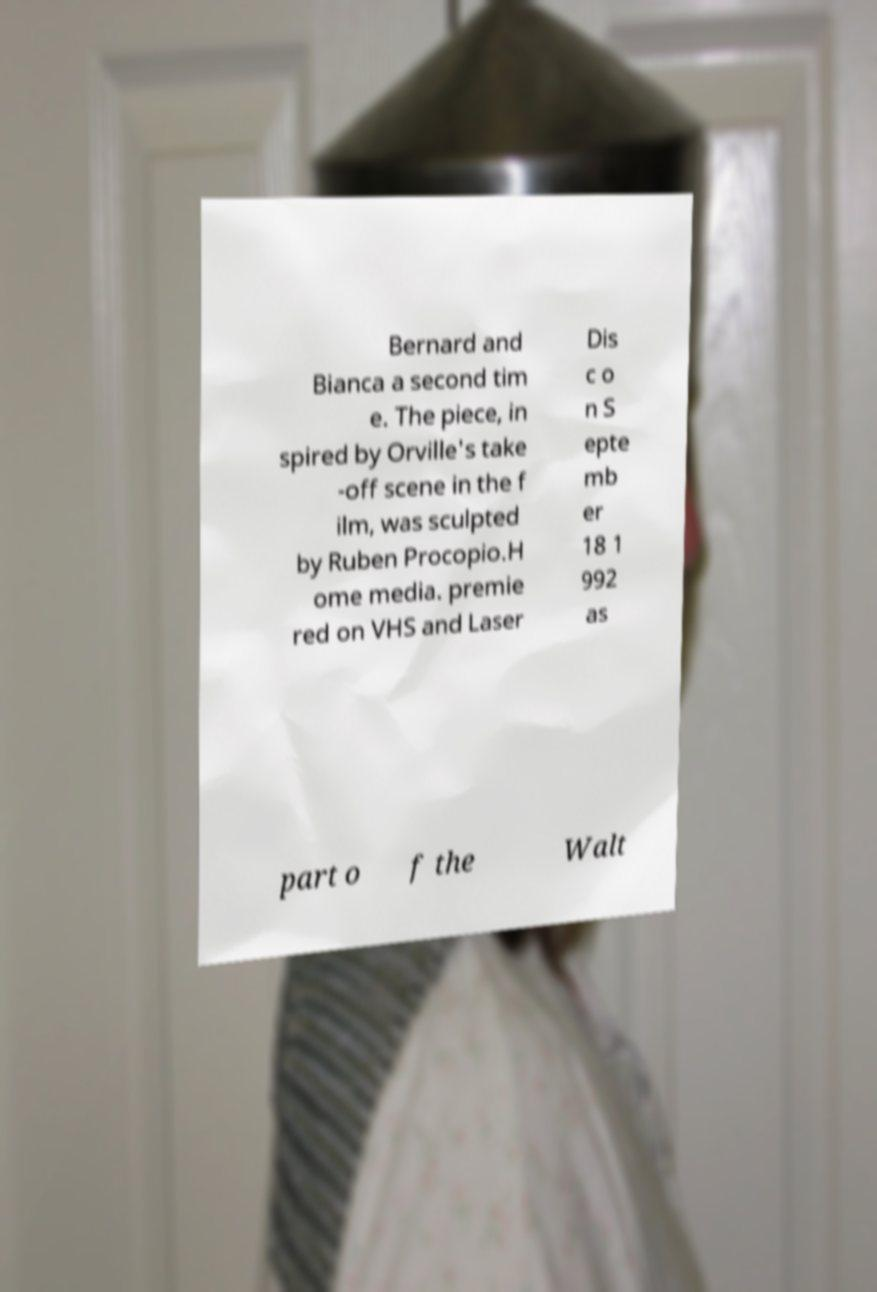Could you assist in decoding the text presented in this image and type it out clearly? Bernard and Bianca a second tim e. The piece, in spired by Orville's take -off scene in the f ilm, was sculpted by Ruben Procopio.H ome media. premie red on VHS and Laser Dis c o n S epte mb er 18 1 992 as part o f the Walt 